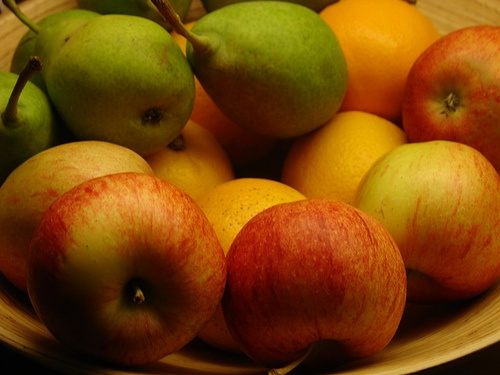Describe the objects in this image and their specific colors. I can see bowl in maroon, black, red, and orange tones, apple in maroon, black, gray, orange, and red tones, orange in gray, orange, maroon, and red tones, orange in gray, orange, red, and maroon tones, and orange in gray, orange, brown, and red tones in this image. 